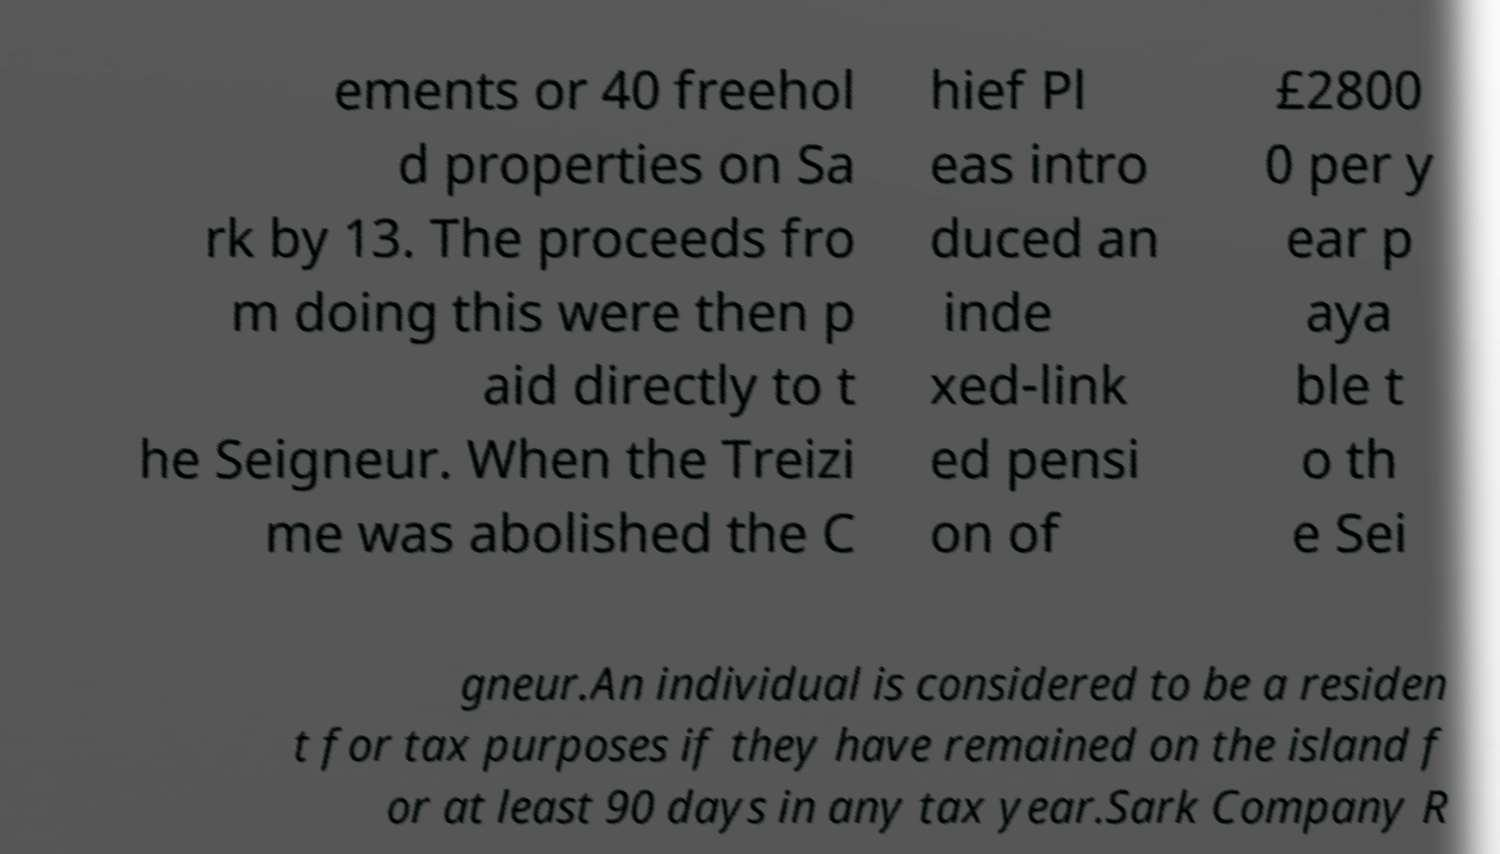What messages or text are displayed in this image? I need them in a readable, typed format. ements or 40 freehol d properties on Sa rk by 13. The proceeds fro m doing this were then p aid directly to t he Seigneur. When the Treizi me was abolished the C hief Pl eas intro duced an inde xed-link ed pensi on of £2800 0 per y ear p aya ble t o th e Sei gneur.An individual is considered to be a residen t for tax purposes if they have remained on the island f or at least 90 days in any tax year.Sark Company R 